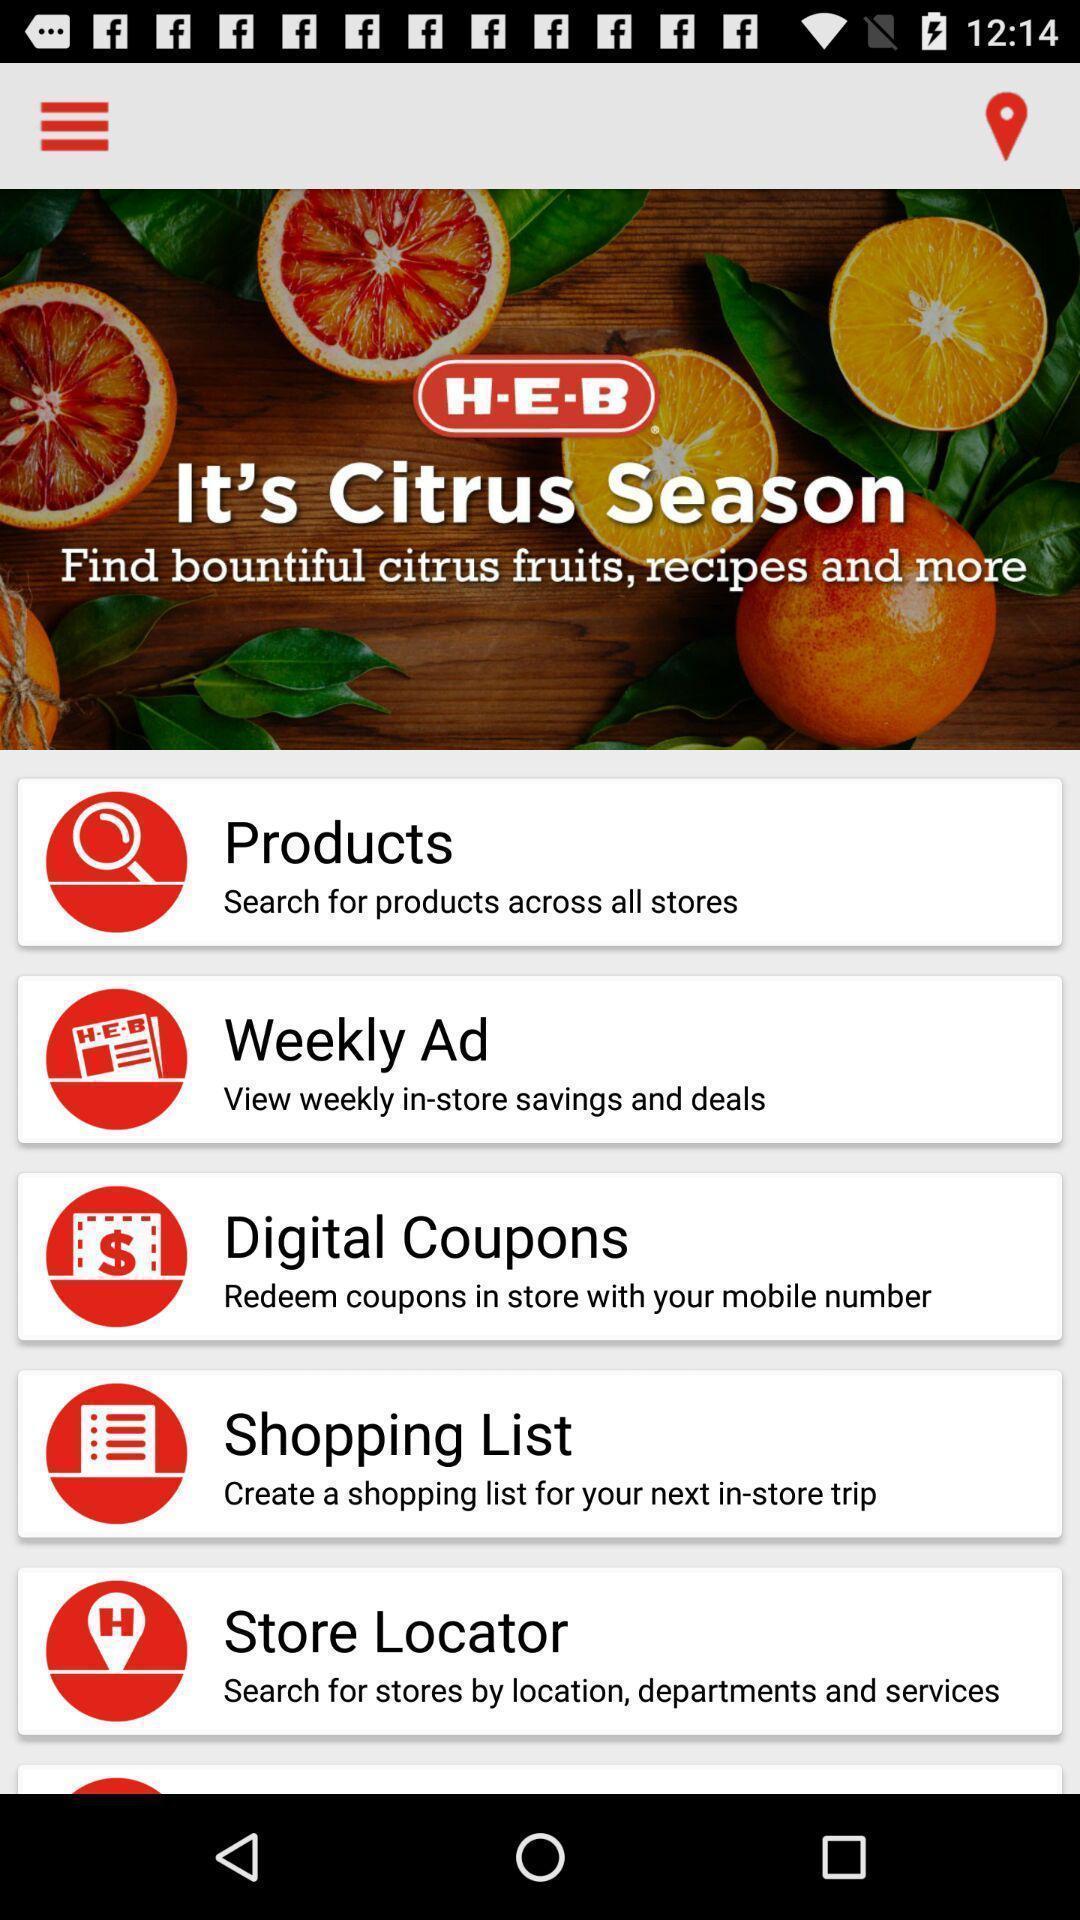Explain the elements present in this screenshot. Screen displaying multiple options in a shopping application. 